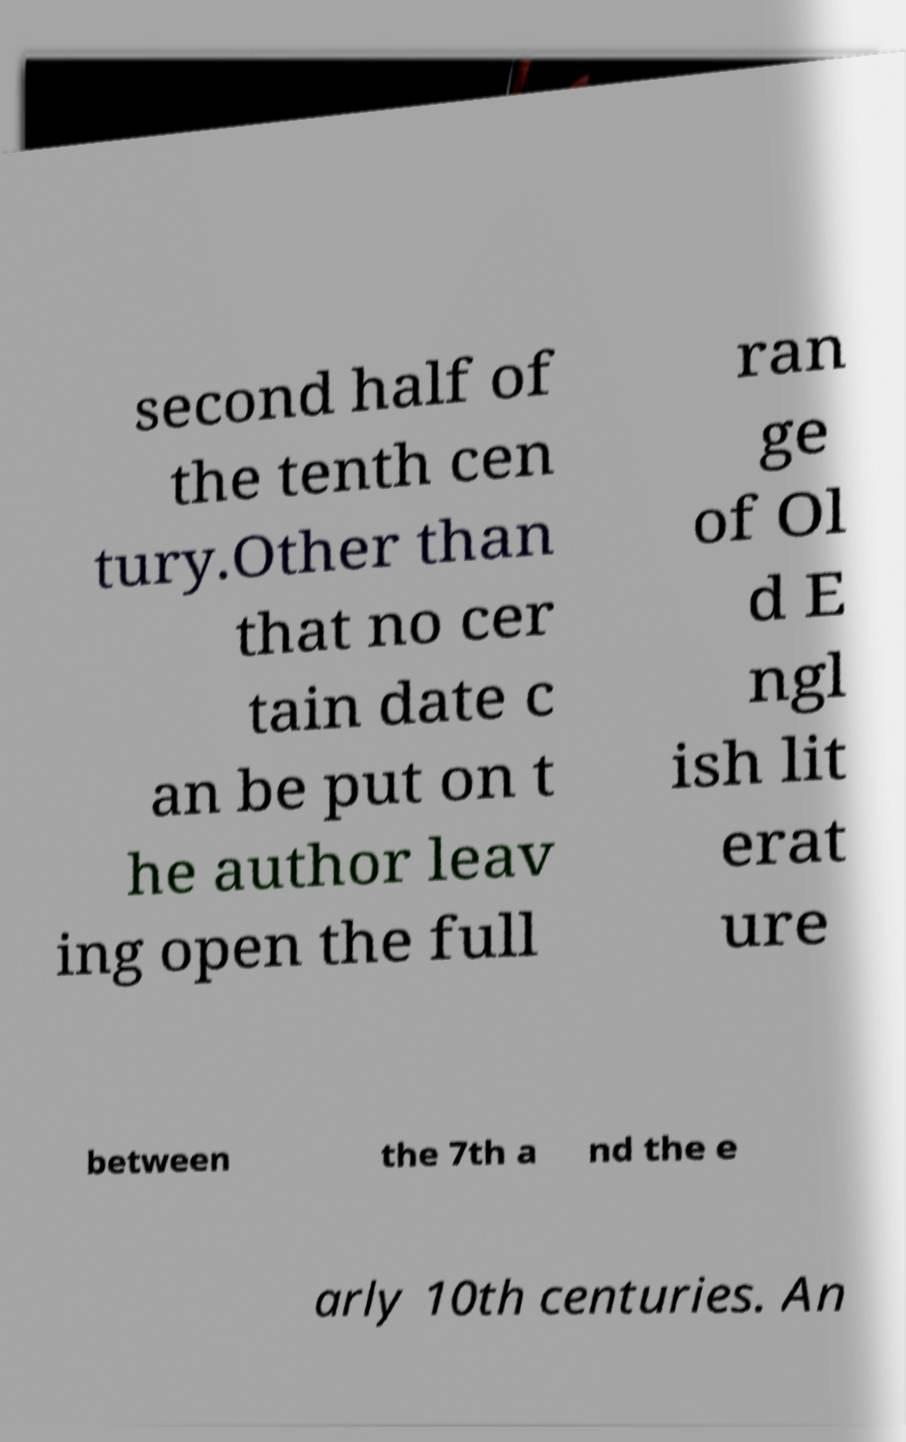Could you assist in decoding the text presented in this image and type it out clearly? second half of the tenth cen tury.Other than that no cer tain date c an be put on t he author leav ing open the full ran ge of Ol d E ngl ish lit erat ure between the 7th a nd the e arly 10th centuries. An 